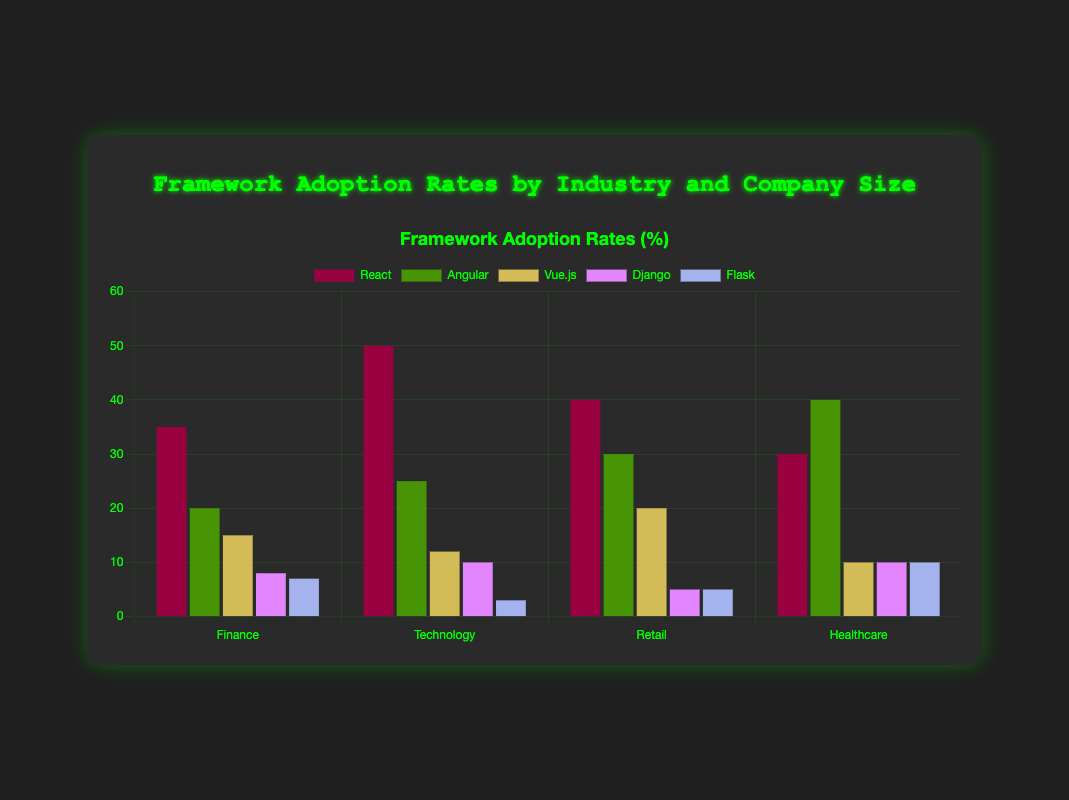What is the most adopted framework in the finance industry? The finance industry shows several frameworks with varying adoption rates. Among them, React has the highest adoption rate at 35%.
Answer: React Which industry has the highest adoption rate for Angular? By examining the adoption rates of Angular across all industries, Healthcare has the highest adoption rate at 40%.
Answer: Healthcare How much higher is the adoption rate of React in Technology compared to Finance? The adoption rate of React in Technology is 50%, while in Finance, it is 35%. The difference is 50% - 35% = 15%.
Answer: 15% What is the total adoption rate for Django across all industries? Summing up the Django adoption rates from all industries: 8% (Finance) + 10% (Technology) + 5% (Retail) + 10% (Healthcare) = 33%.
Answer: 33% Which framework has a uniform adoption rate across all industries? Flask has a uniform adoption rate of 10% in Healthcare, 5% in both Retail and Healthcare, and 7% in Finance and 3% in Technology. No framework has a perfectly uniform rate across all, but Flask comes close in similar ranges.
Answer: Flask Is the adoption rate of Vue.js in Finance higher or lower than in Retail? Vue.js has an adoption rate of 15% in Finance and 20% in Retail. Comparing these rates, 15% is lower than 20%.
Answer: Lower In which company size category is React most widely adopted? To find the highest adoption rate of React based on company size, we see the adoption rates are: <50 (35%), 50-200 (50%), 200-500 (40%), and >500 (30%). The highest adoption rate is in companies with 50-200 employees at 50%.
Answer: 50-200 Which framework has the lowest adoption rate in Technology industry? Flask has the lowest adoption rate in the Technology industry at 3%.
Answer: Flask 